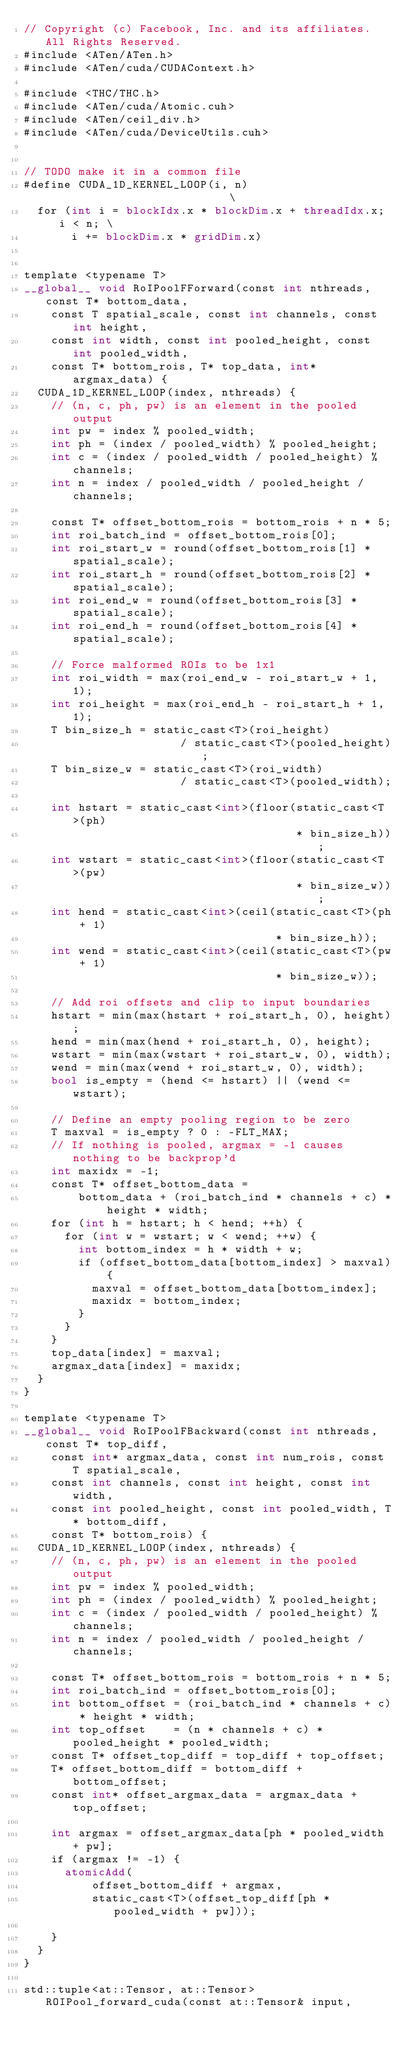Convert code to text. <code><loc_0><loc_0><loc_500><loc_500><_Cuda_>// Copyright (c) Facebook, Inc. and its affiliates. All Rights Reserved.
#include <ATen/ATen.h>
#include <ATen/cuda/CUDAContext.h>

#include <THC/THC.h>
#include <ATen/cuda/Atomic.cuh>
#include <ATen/ceil_div.h>
#include <ATen/cuda/DeviceUtils.cuh>


// TODO make it in a common file
#define CUDA_1D_KERNEL_LOOP(i, n)                            \
  for (int i = blockIdx.x * blockDim.x + threadIdx.x; i < n; \
       i += blockDim.x * gridDim.x)


template <typename T>
__global__ void RoIPoolFForward(const int nthreads, const T* bottom_data,
    const T spatial_scale, const int channels, const int height,
    const int width, const int pooled_height, const int pooled_width,
    const T* bottom_rois, T* top_data, int* argmax_data) {
  CUDA_1D_KERNEL_LOOP(index, nthreads) {
    // (n, c, ph, pw) is an element in the pooled output
    int pw = index % pooled_width;
    int ph = (index / pooled_width) % pooled_height;
    int c = (index / pooled_width / pooled_height) % channels;
    int n = index / pooled_width / pooled_height / channels;

    const T* offset_bottom_rois = bottom_rois + n * 5;
    int roi_batch_ind = offset_bottom_rois[0];
    int roi_start_w = round(offset_bottom_rois[1] * spatial_scale);
    int roi_start_h = round(offset_bottom_rois[2] * spatial_scale);
    int roi_end_w = round(offset_bottom_rois[3] * spatial_scale);
    int roi_end_h = round(offset_bottom_rois[4] * spatial_scale);

    // Force malformed ROIs to be 1x1
    int roi_width = max(roi_end_w - roi_start_w + 1, 1);
    int roi_height = max(roi_end_h - roi_start_h + 1, 1);
    T bin_size_h = static_cast<T>(roi_height)
                       / static_cast<T>(pooled_height);
    T bin_size_w = static_cast<T>(roi_width)
                       / static_cast<T>(pooled_width);

    int hstart = static_cast<int>(floor(static_cast<T>(ph)
                                        * bin_size_h));
    int wstart = static_cast<int>(floor(static_cast<T>(pw)
                                        * bin_size_w));
    int hend = static_cast<int>(ceil(static_cast<T>(ph + 1)
                                     * bin_size_h));
    int wend = static_cast<int>(ceil(static_cast<T>(pw + 1)
                                     * bin_size_w));

    // Add roi offsets and clip to input boundaries
    hstart = min(max(hstart + roi_start_h, 0), height);
    hend = min(max(hend + roi_start_h, 0), height);
    wstart = min(max(wstart + roi_start_w, 0), width);
    wend = min(max(wend + roi_start_w, 0), width);
    bool is_empty = (hend <= hstart) || (wend <= wstart);

    // Define an empty pooling region to be zero
    T maxval = is_empty ? 0 : -FLT_MAX;
    // If nothing is pooled, argmax = -1 causes nothing to be backprop'd
    int maxidx = -1;
    const T* offset_bottom_data =
        bottom_data + (roi_batch_ind * channels + c) * height * width;
    for (int h = hstart; h < hend; ++h) {
      for (int w = wstart; w < wend; ++w) {
        int bottom_index = h * width + w;
        if (offset_bottom_data[bottom_index] > maxval) {
          maxval = offset_bottom_data[bottom_index];
          maxidx = bottom_index;
        }
      }
    }
    top_data[index] = maxval;
    argmax_data[index] = maxidx;
  }
}

template <typename T>
__global__ void RoIPoolFBackward(const int nthreads, const T* top_diff,
    const int* argmax_data, const int num_rois, const T spatial_scale,
    const int channels, const int height, const int width,
    const int pooled_height, const int pooled_width, T* bottom_diff,
    const T* bottom_rois) {
  CUDA_1D_KERNEL_LOOP(index, nthreads) {
    // (n, c, ph, pw) is an element in the pooled output
    int pw = index % pooled_width;
    int ph = (index / pooled_width) % pooled_height;
    int c = (index / pooled_width / pooled_height) % channels;
    int n = index / pooled_width / pooled_height / channels;

    const T* offset_bottom_rois = bottom_rois + n * 5;
    int roi_batch_ind = offset_bottom_rois[0];
    int bottom_offset = (roi_batch_ind * channels + c) * height * width;
    int top_offset    = (n * channels + c) * pooled_height * pooled_width;
    const T* offset_top_diff = top_diff + top_offset;
    T* offset_bottom_diff = bottom_diff + bottom_offset;
    const int* offset_argmax_data = argmax_data + top_offset;

    int argmax = offset_argmax_data[ph * pooled_width + pw];
    if (argmax != -1) {
      atomicAdd(
          offset_bottom_diff + argmax,
          static_cast<T>(offset_top_diff[ph * pooled_width + pw]));

    }
  }
}

std::tuple<at::Tensor, at::Tensor> ROIPool_forward_cuda(const at::Tensor& input,</code> 